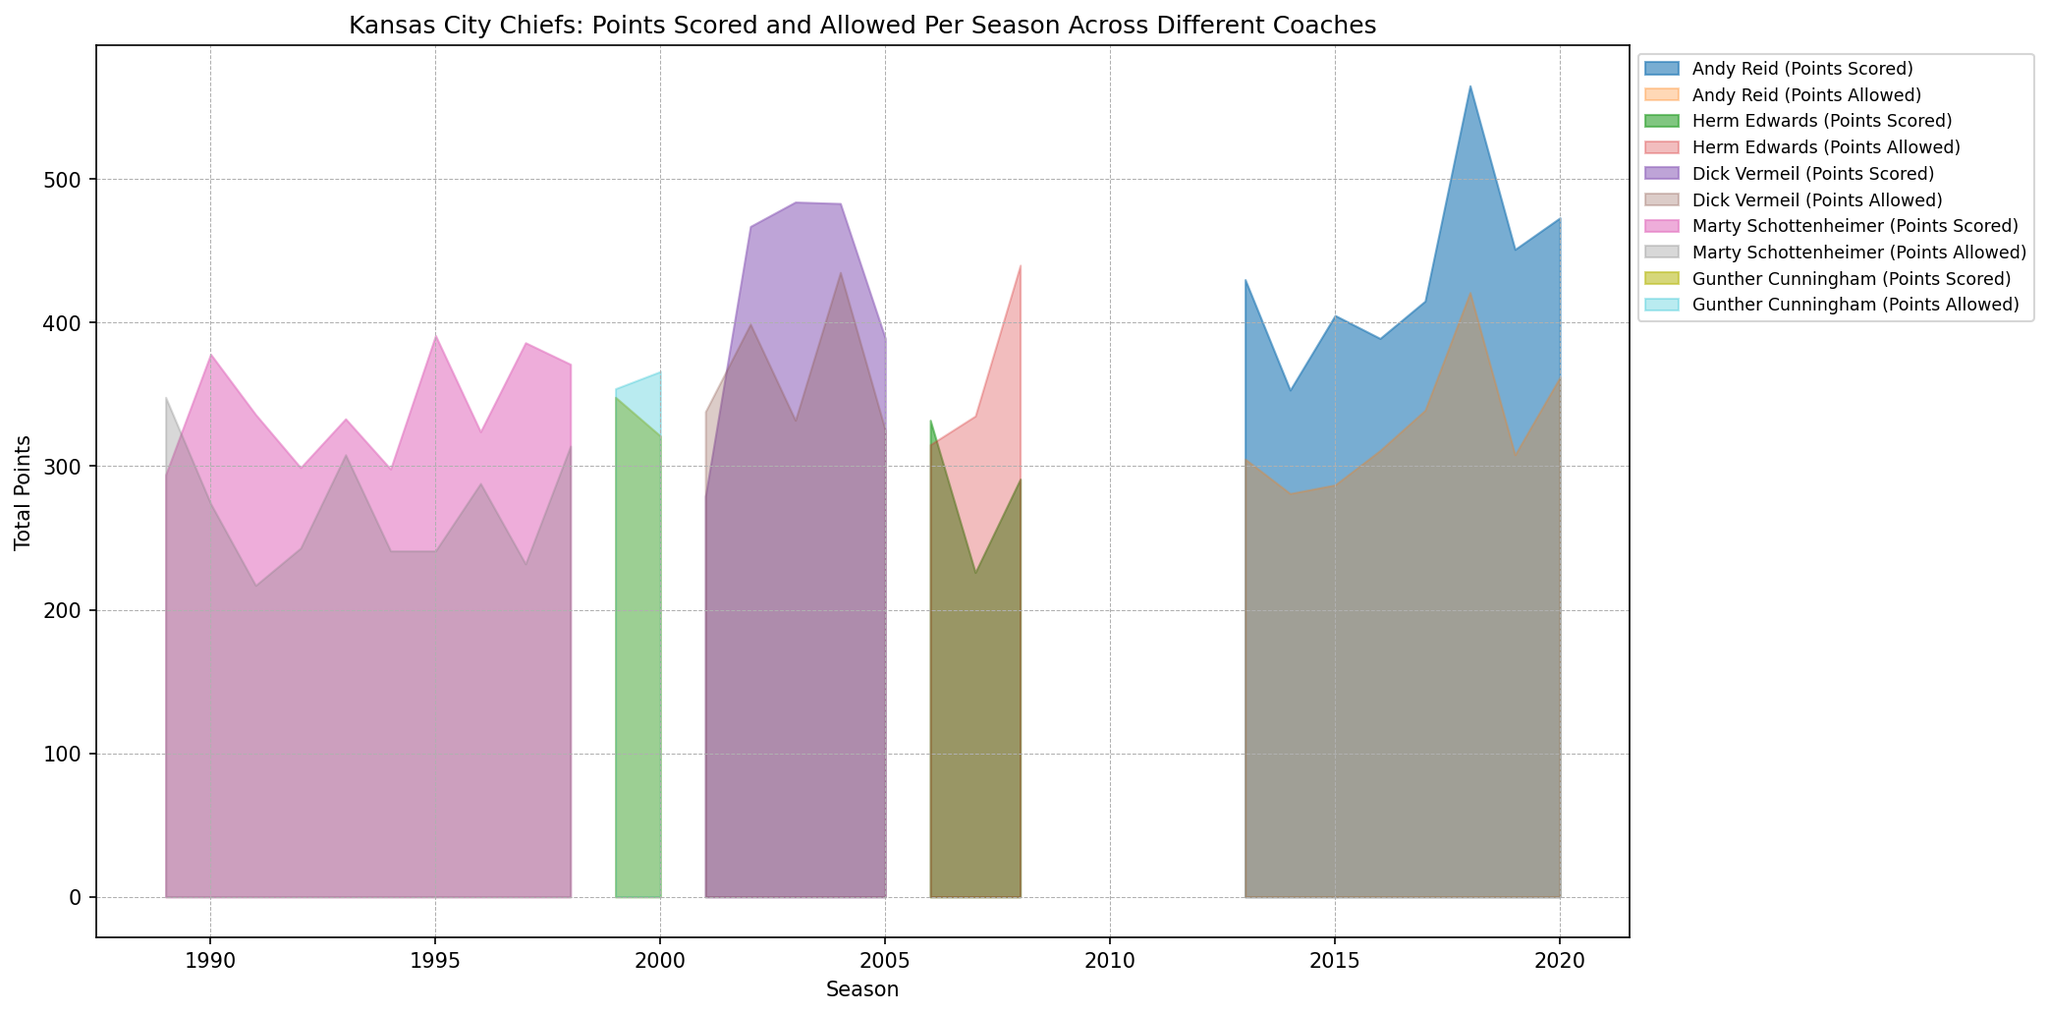Which coach's team had the highest total points scored in a single season? By looking at the peaks in the area chart corresponding to different coaches, Andy Reid's team in 2018 scored the highest points.
Answer: Andy Reid (2018) Which coach had the lowest total points allowed in a single season? By identifying the lowest valleys in the area chart, Marty Schottenheimer's team allowed the fewest points in 1991.
Answer: Marty Schottenheimer (1991) Comparing Andy Reid and Herm Edwards, which coach's team had a higher average total points scored per season? Calculate the average points scored for each coach by summing and dividing by the number of seasons. Andy Reid: (430+353+405+389+415+565+451+473)/8 = 435.125. Herm Edwards: (332+226+291)/3 = 283.
Answer: Andy Reid In which season did Dick Vermeil's team score nearly twice as many points as the previous season? Compare the points scored by Dick Vermeil's team season by season. From 2001 (279 points) to 2002 (467 points), there is a significant increase, but 2003 (484 points) is not twice of 2002. Hence, it's between 2001 and 2002 where the scored points almost doubled.
Answer: 2002 During which coach's tenure did the team consistently allow fewer points than they scored? Identify stretches in the area chart where the total points allowed are consistently below points scored. Marty Schottenheimer's tenure shows consistent performance where points allowed are always below points scored.
Answer: Marty Schottenheimer Which coach's team had the largest gap between total points scored and allowed in a single season? Look for the largest vertical distance between the two areas in a single season. Andy Reid's team in 2018 had the largest gap between 565 points scored and 421 points allowed.
Answer: Andy Reid (2018) What trend can be observed in Andy Reid's points scored from 2013 to 2020? Trace the area corresponding to Andy Reid’s points scored. There is a noticeable upward trend in general, peaking notably in 2018.
Answer: Increasing trend How did the total points allowed compare between Gunther Cunningham's two seasons? Review the heights of the areas corresponding to points allowed for Gunther Cunningham. In 1999, the total points allowed were 354 and in 2000, it was 366.
Answer: 2000 had more points allowed During Herm Edwards' tenure, in which season did the team score the fewest total points? Identify the lowest point in the area chart for Herm Edwards. The fewest points scored was in 2007 with 226 points.
Answer: 2007 Which coach had the closest points scored and allowed in a season? Look for the two areas aligning closely. In 1999, under Gunther Cunningham, points scored were 348 and allowed were 354.
Answer: Gunther Cunningham (1999) 